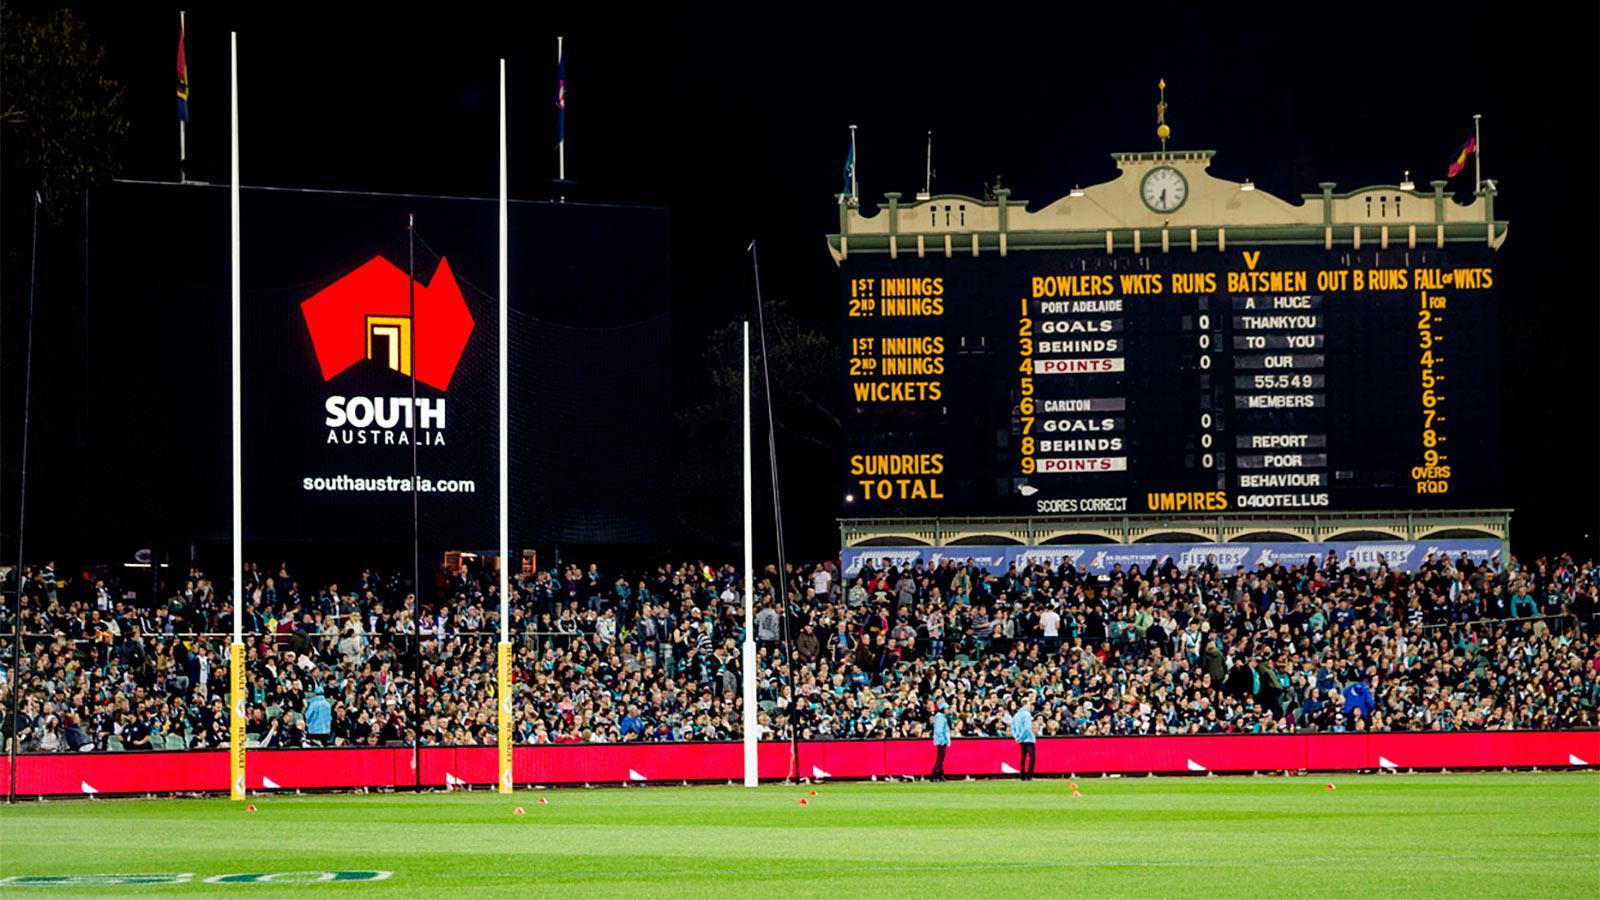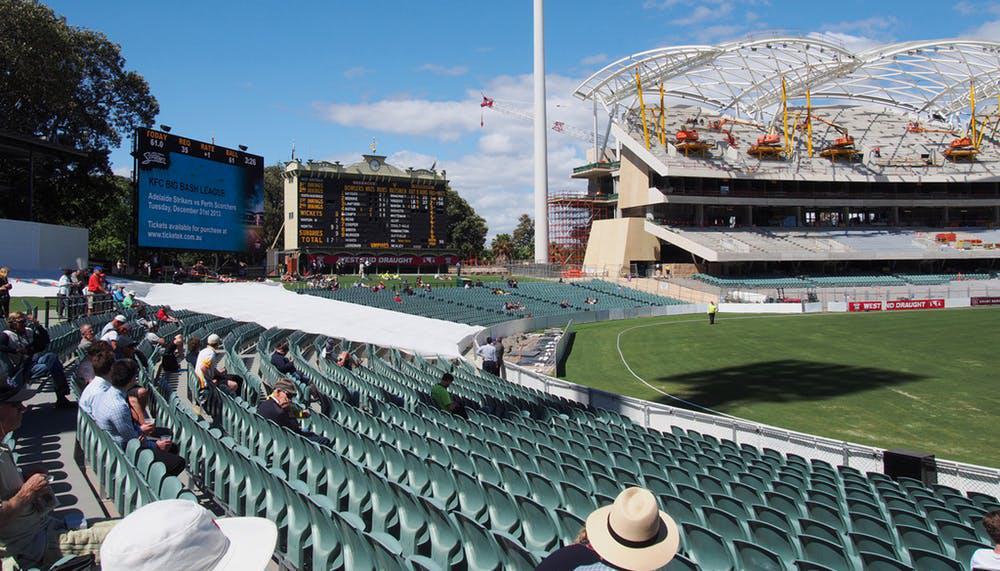The first image is the image on the left, the second image is the image on the right. Assess this claim about the two images: "A blue advertisement sits beneath the scoreboard in the image on the left.". Correct or not? Answer yes or no. Yes. 